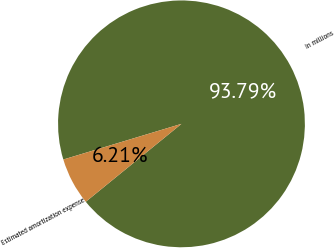Convert chart. <chart><loc_0><loc_0><loc_500><loc_500><pie_chart><fcel>In millions<fcel>Estimated amortization expense<nl><fcel>93.79%<fcel>6.21%<nl></chart> 